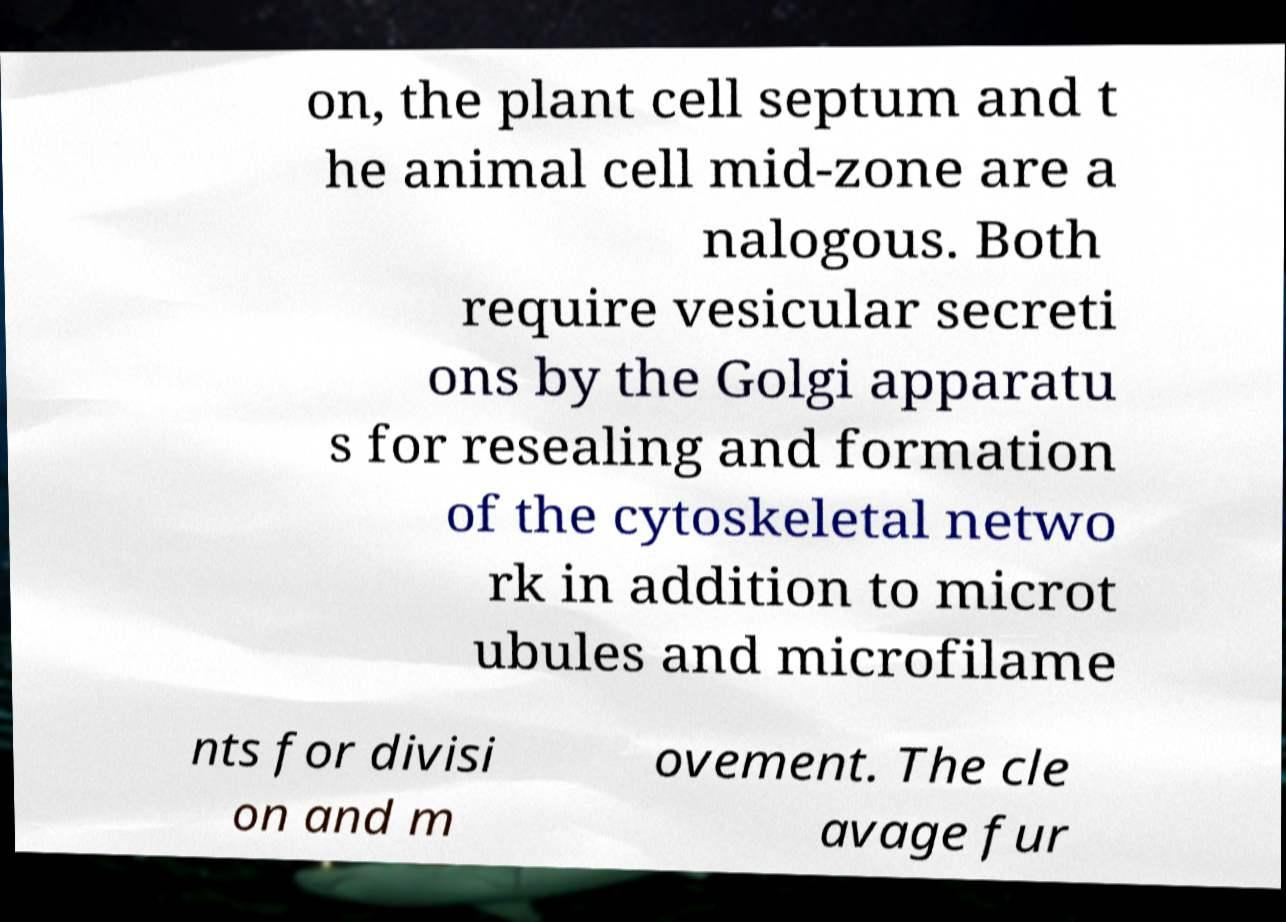Please read and relay the text visible in this image. What does it say? on, the plant cell septum and t he animal cell mid-zone are a nalogous. Both require vesicular secreti ons by the Golgi apparatu s for resealing and formation of the cytoskeletal netwo rk in addition to microt ubules and microfilame nts for divisi on and m ovement. The cle avage fur 